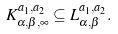<formula> <loc_0><loc_0><loc_500><loc_500>K ^ { a _ { 1 } , a _ { 2 } } _ { \alpha , \beta , \infty } \subseteq L ^ { a _ { 1 } , a _ { 2 } } _ { \alpha , \beta } .</formula> 